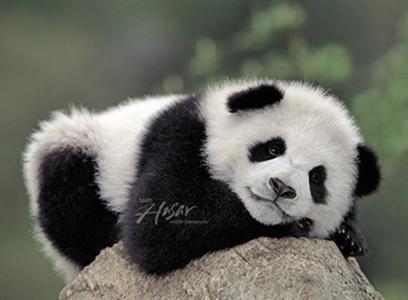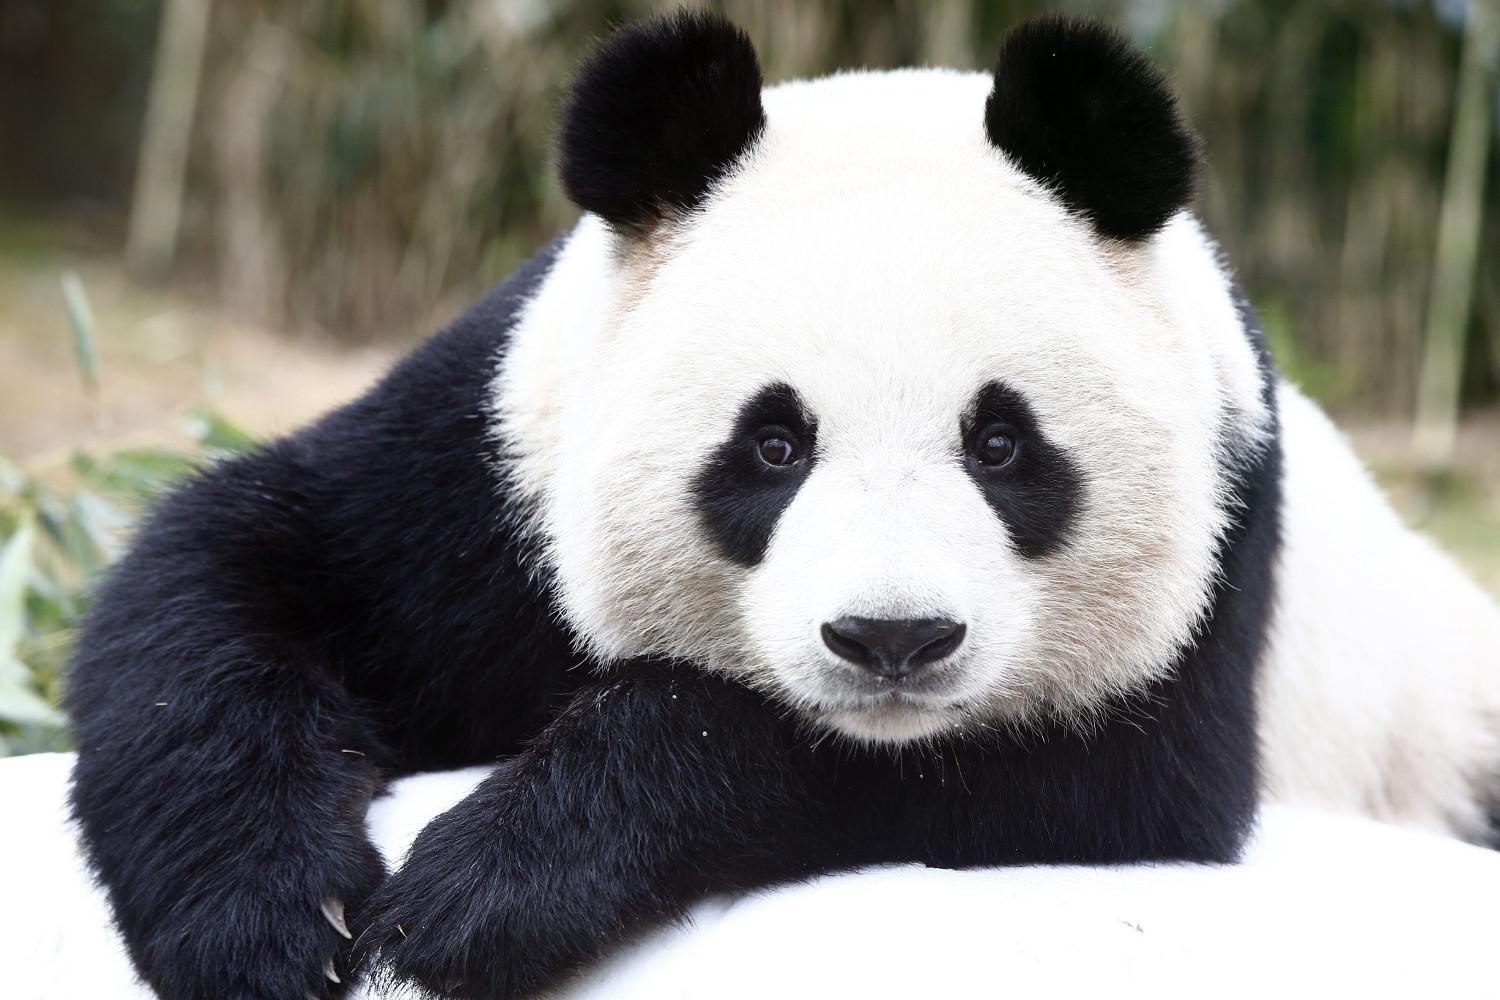The first image is the image on the left, the second image is the image on the right. Considering the images on both sides, is "In one of the images, a single panda is looking straight at the camera with its tongue visible." valid? Answer yes or no. No. The first image is the image on the left, the second image is the image on the right. Analyze the images presented: Is the assertion "Both of one panda's front paws are extended forward and visible." valid? Answer yes or no. Yes. 